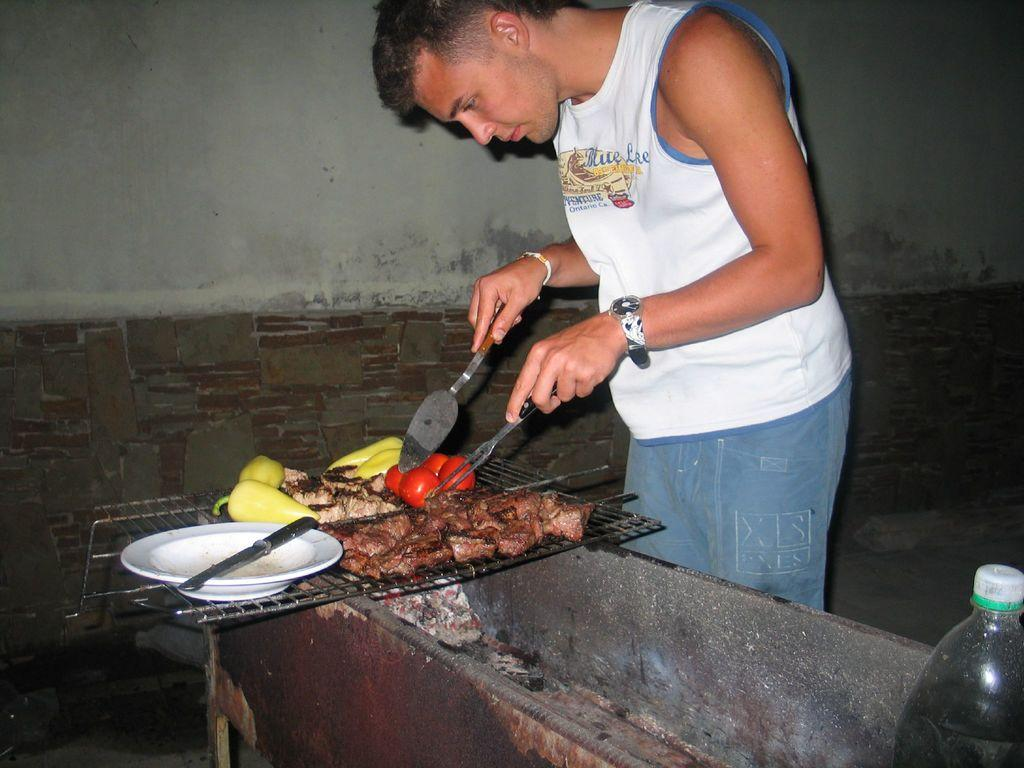What is the main subject of the image? There is a person standing in the center of the image. What is the person doing in the image? The person is cutting tomatoes. What is the person holding in the image? The person is holding a knife. What can be seen in the background of the image? There is a wall, a plate, a table, a knife (presumably different from the one the person is holding), and a bottle in the background of the image. Is there a girl helping the person in the image? There is no girl present in the image, nor is there any indication of someone helping the person. What type of building can be seen in the background of the image? There is no building visible in the image; only a wall, a plate, a table, a knife, and a bottle are present in the background. 